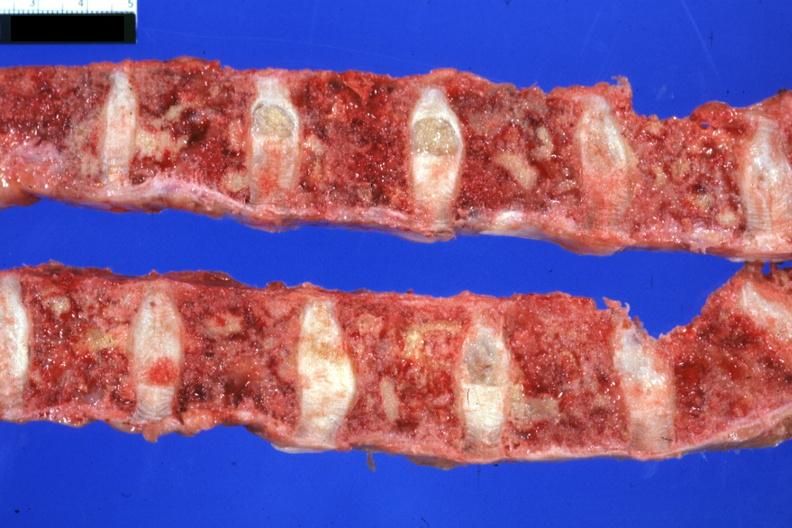what is excellent multiple lesions sigmoid?
Answer the question using a single word or phrase. Colon papillary adenocarcinoma 6mo post colon resection with complications 